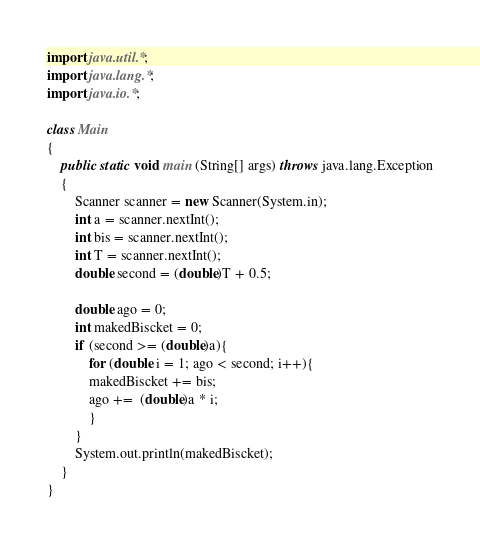Convert code to text. <code><loc_0><loc_0><loc_500><loc_500><_Java_>import java.util.*;
import java.lang.*;
import java.io.*;

class Main
{
	public static void main (String[] args) throws java.lang.Exception
	{
	    Scanner scanner = new Scanner(System.in);
        int a = scanner.nextInt();
        int bis = scanner.nextInt();
        int T = scanner.nextInt();
        double second = (double)T + 0.5;
        
        double ago = 0;
        int makedBiscket = 0;
        if (second >= (double)a){
            for (double i = 1; ago < second; i++){
        	makedBiscket += bis;
        	ago +=  (double)a * i;
    		}	
        }
        System.out.println(makedBiscket);
	}
}</code> 